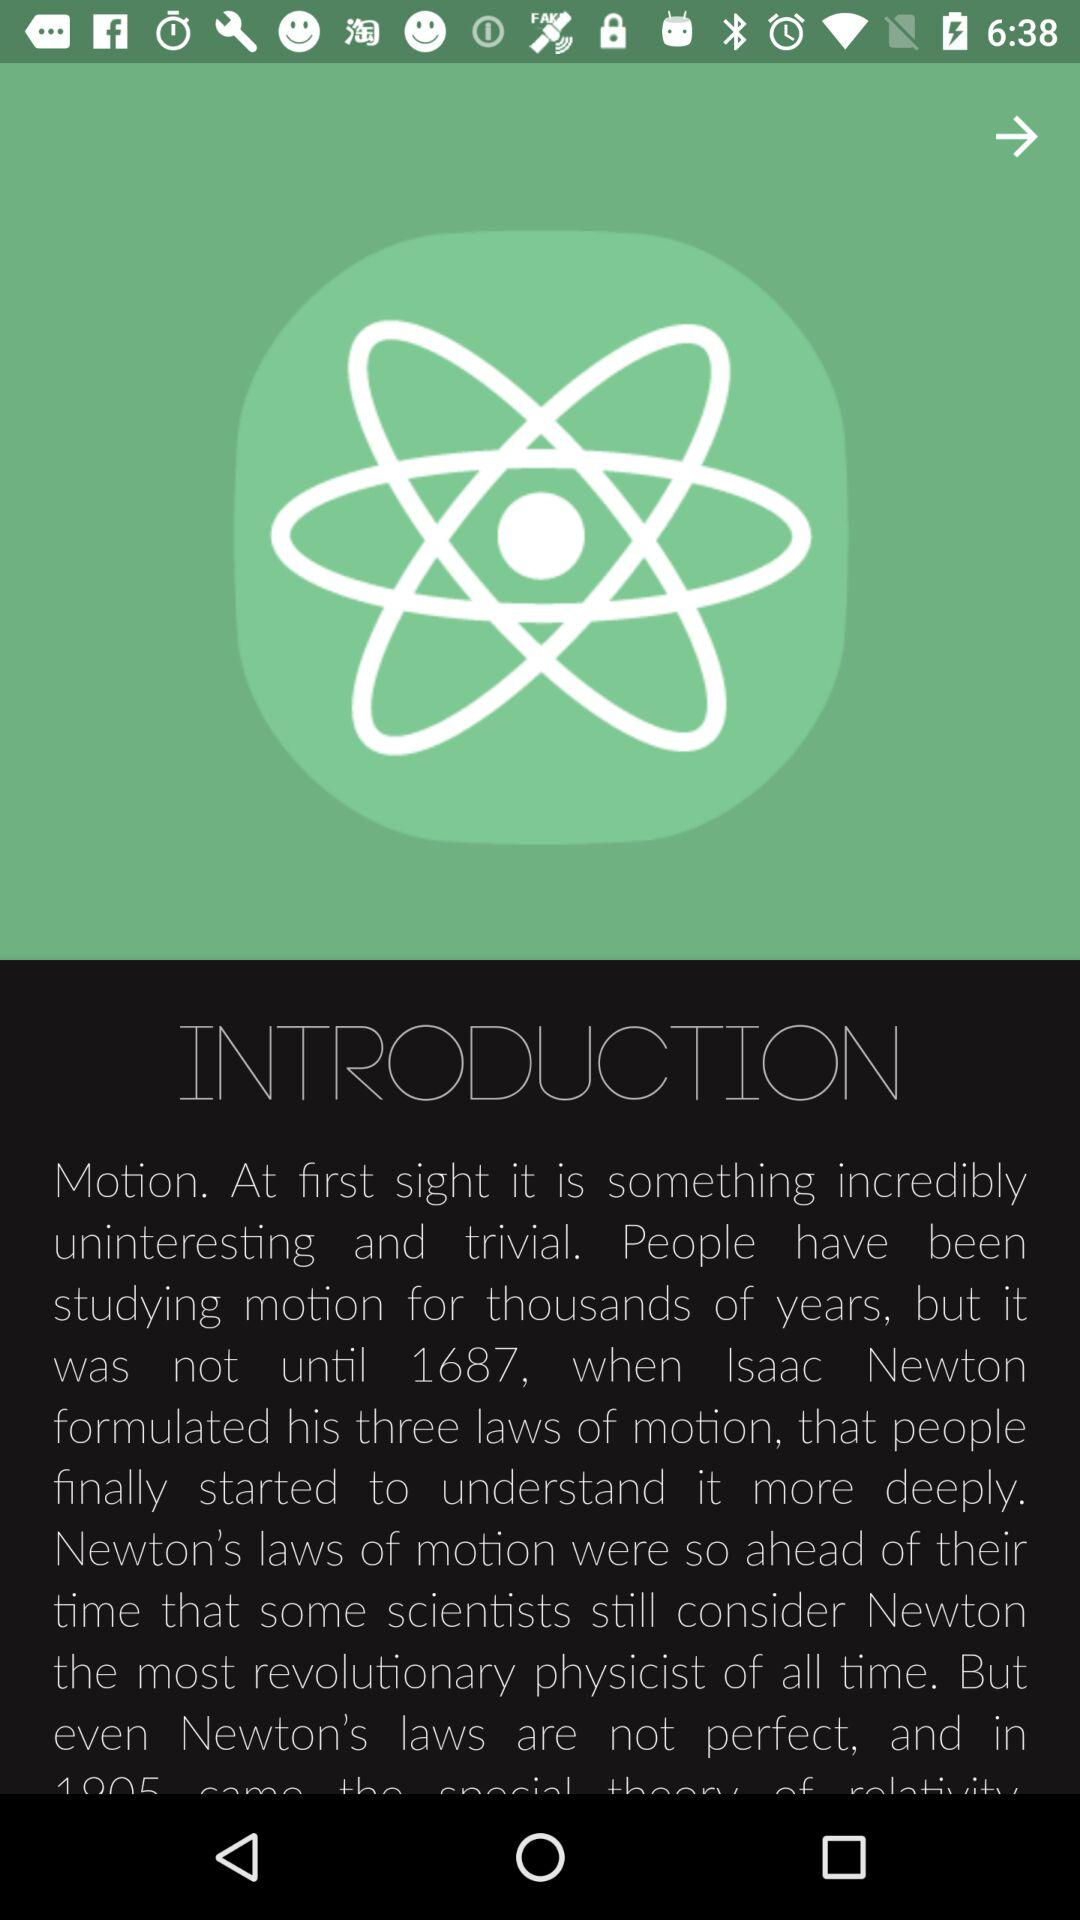How many laws of motion has Newton formulated? Newton has formulated three laws of motion. 